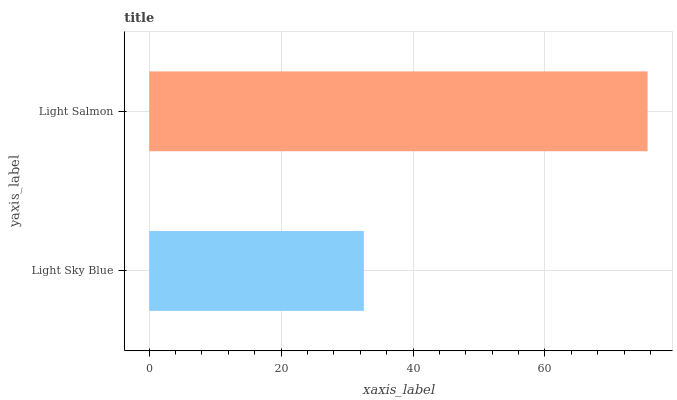Is Light Sky Blue the minimum?
Answer yes or no. Yes. Is Light Salmon the maximum?
Answer yes or no. Yes. Is Light Salmon the minimum?
Answer yes or no. No. Is Light Salmon greater than Light Sky Blue?
Answer yes or no. Yes. Is Light Sky Blue less than Light Salmon?
Answer yes or no. Yes. Is Light Sky Blue greater than Light Salmon?
Answer yes or no. No. Is Light Salmon less than Light Sky Blue?
Answer yes or no. No. Is Light Salmon the high median?
Answer yes or no. Yes. Is Light Sky Blue the low median?
Answer yes or no. Yes. Is Light Sky Blue the high median?
Answer yes or no. No. Is Light Salmon the low median?
Answer yes or no. No. 